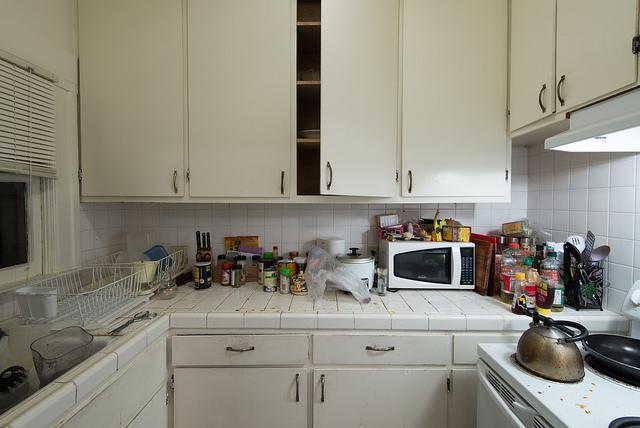What are the two rectangular baskets on the left counter for?
Make your selection from the four choices given to correctly answer the question.
Options: Rinse dishes, fruits, decorations, dish draining. Dish draining. Why is there a dish drainer on the counter?
Make your selection from the four choices given to correctly answer the question.
Options: Ambiance, cooking utensil, vegetable storage, no dishwasher. No dishwasher. 